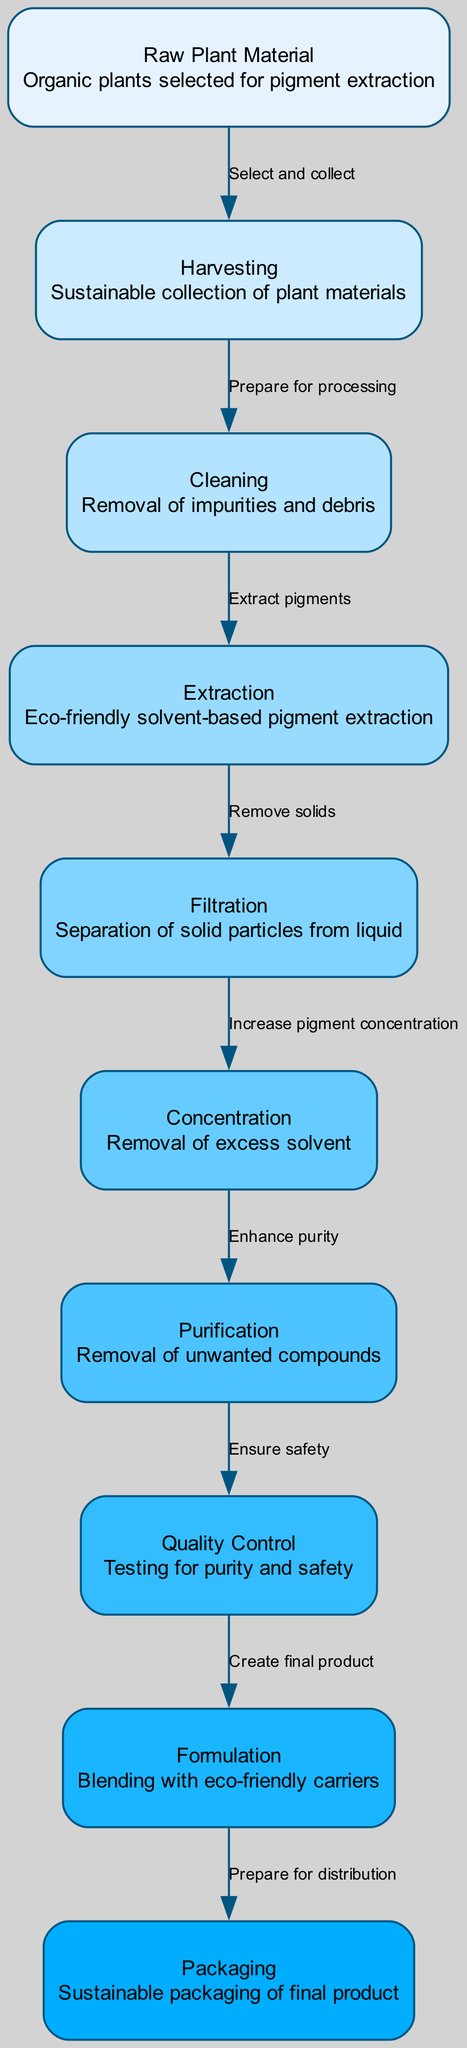What is the starting point of the process? The diagram begins at the "Raw Plant Material" node, which serves as the initial input for pigment extraction.
Answer: Raw Plant Material How many nodes are in the diagram? By counting each unique step in the process outlined in the diagram, there are a total of ten nodes that represent different stages of extraction and processing.
Answer: Ten What action occurs between Cleaning and Extraction? The edge leading from Cleaning to Extraction is labeled as "Extract pigments," indicating the action taken after Cleaning.
Answer: Extract pigments What is the final step in the diagram? The last node in the flow of the diagram represents "Packaging," indicating that it is the final stage before the product is ready for distribution.
Answer: Packaging Which node is directly connected to Quality Control? Quality Control has one outgoing edge leading to the Formulation node, indicating it directly connects to that step in the process.
Answer: Formulation What is the role of the Concentration step? The Concentration step in the diagram is labeled as "Removal of excess solvent," indicating its role in increasing pigment concentration.
Answer: Removal of excess solvent How does the process transition from Extraction to Filtration? The edge connecting Extraction to Filtration is labeled "Remove solids," indicating that during this transition, solid particles are eliminated from the liquid mixture.
Answer: Remove solids What does the Purification node achieve? The Purification step is described as "Removal of unwanted compounds," signifying that its purpose is to enhance the quality of the extracted pigments.
Answer: Removal of unwanted compounds Which two nodes are linked by the edge labeled "Prepare for processing"? The edge labeled "Prepare for processing" connects the Harvesting node to the Cleaning node, indicating the sequential nature of these steps.
Answer: Harvesting and Cleaning 